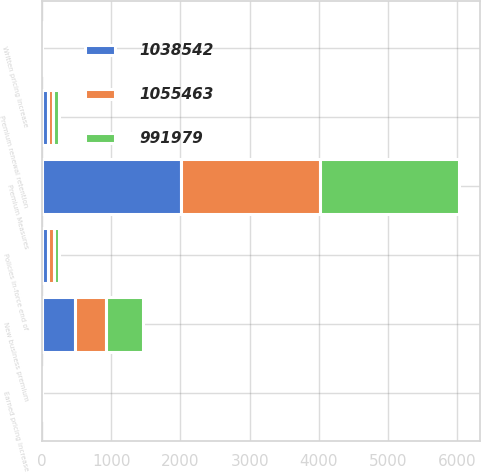Convert chart. <chart><loc_0><loc_0><loc_500><loc_500><stacked_bar_chart><ecel><fcel>Premium Measures<fcel>New business premium<fcel>Premium renewal retention<fcel>Written pricing increase<fcel>Earned pricing increase<fcel>Policies in-force end of<nl><fcel>1.05546e+06<fcel>2008<fcel>446<fcel>82<fcel>2<fcel>2<fcel>84<nl><fcel>1.03854e+06<fcel>2007<fcel>481<fcel>84<fcel>2<fcel>1<fcel>84<nl><fcel>991979<fcel>2006<fcel>533<fcel>87<fcel>1<fcel>1<fcel>84<nl></chart> 